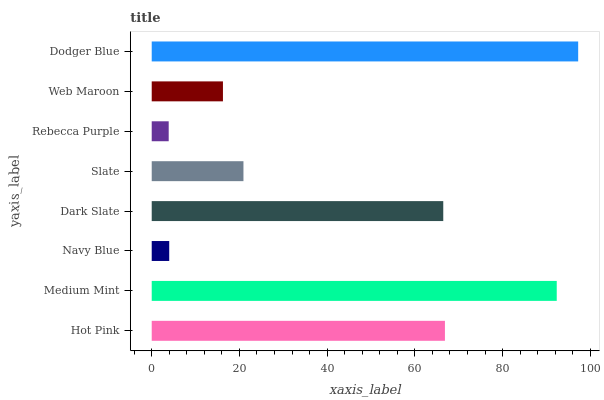Is Rebecca Purple the minimum?
Answer yes or no. Yes. Is Dodger Blue the maximum?
Answer yes or no. Yes. Is Medium Mint the minimum?
Answer yes or no. No. Is Medium Mint the maximum?
Answer yes or no. No. Is Medium Mint greater than Hot Pink?
Answer yes or no. Yes. Is Hot Pink less than Medium Mint?
Answer yes or no. Yes. Is Hot Pink greater than Medium Mint?
Answer yes or no. No. Is Medium Mint less than Hot Pink?
Answer yes or no. No. Is Dark Slate the high median?
Answer yes or no. Yes. Is Slate the low median?
Answer yes or no. Yes. Is Hot Pink the high median?
Answer yes or no. No. Is Dark Slate the low median?
Answer yes or no. No. 